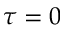<formula> <loc_0><loc_0><loc_500><loc_500>\tau = 0</formula> 